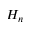Convert formula to latex. <formula><loc_0><loc_0><loc_500><loc_500>H _ { n }</formula> 